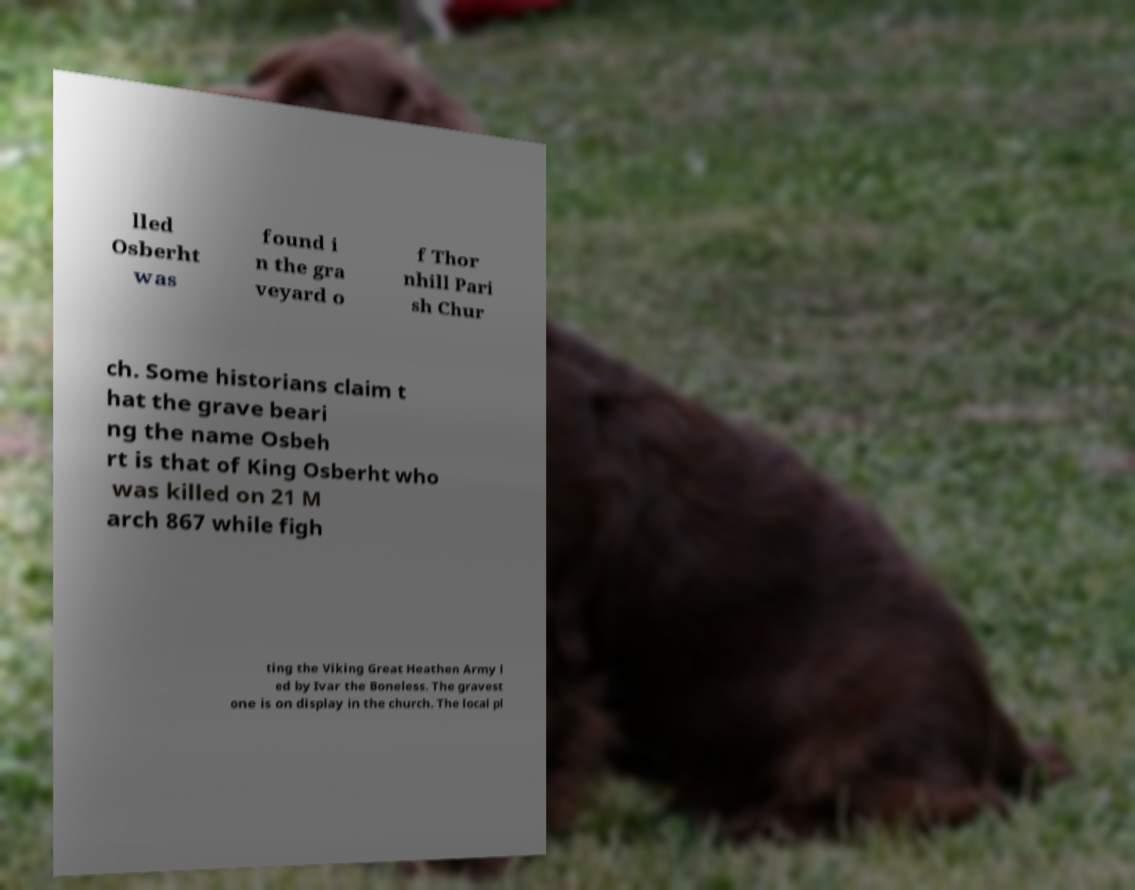I need the written content from this picture converted into text. Can you do that? lled Osberht was found i n the gra veyard o f Thor nhill Pari sh Chur ch. Some historians claim t hat the grave beari ng the name Osbeh rt is that of King Osberht who was killed on 21 M arch 867 while figh ting the Viking Great Heathen Army l ed by Ivar the Boneless. The gravest one is on display in the church. The local pl 